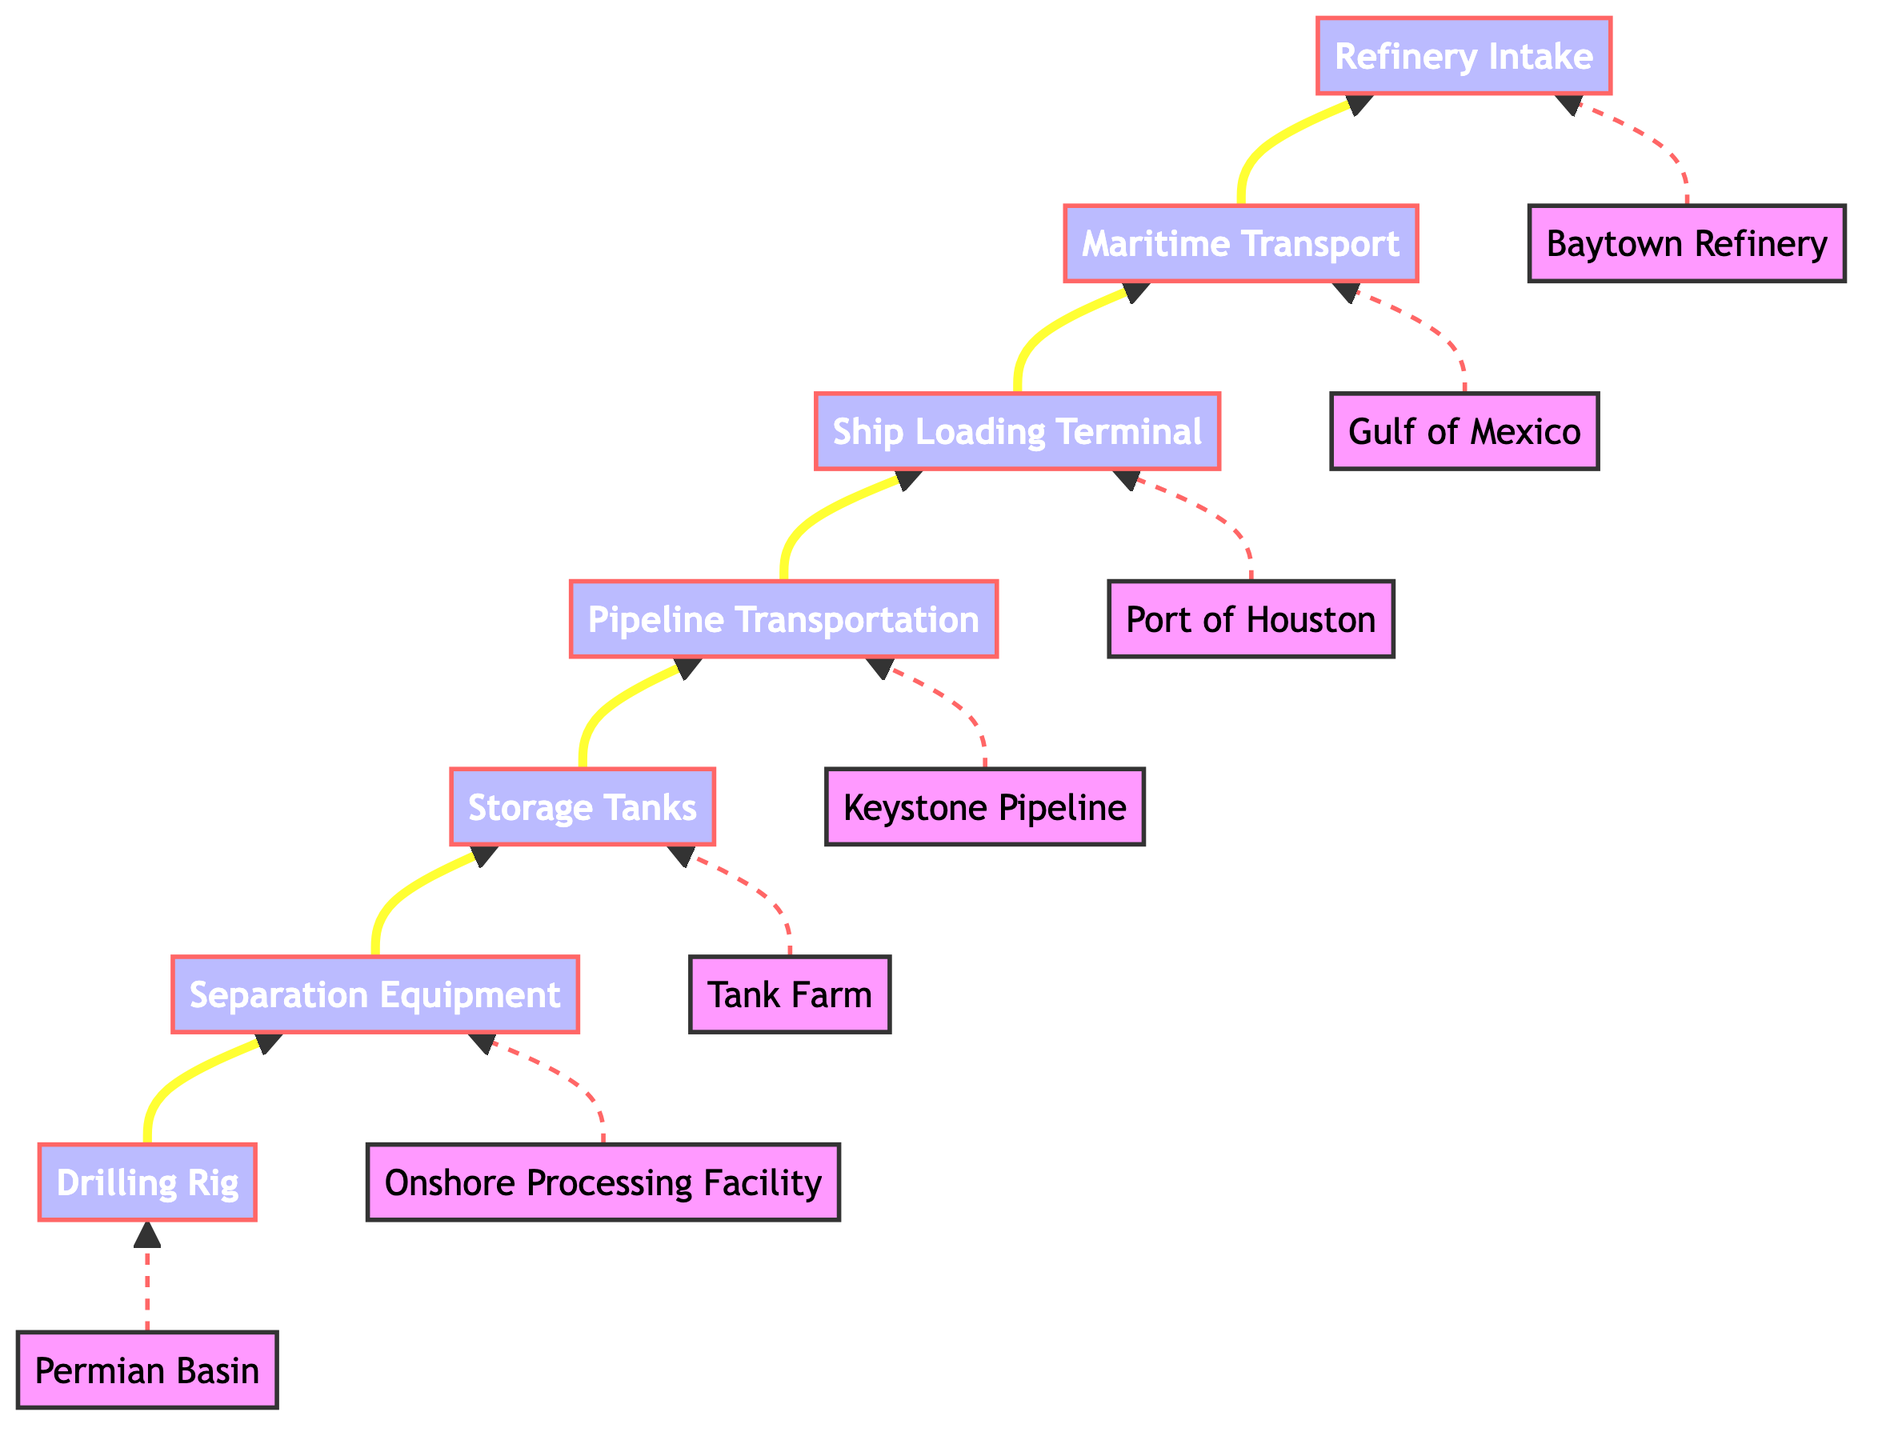What is the starting point of the oil transportation process? The first stage in the process as per the diagram is labeled "Drilling Rig," indicating that this is where crude oil extraction begins.
Answer: Drilling Rig How many stages are there in the oil transportation process? There are a total of seven stages presented in the diagram: Drilling Rig, Separation Equipment, Storage Tanks, Pipeline Transportation, Ship Loading Terminal, Maritime Transport, and Refinery Intake.
Answer: 7 What is the final destination of the oil in the process? The last stage depicted in the flow chart is "Refinery Intake," which indicates that the crude oil is finally received at the refinery for processing.
Answer: Refinery Intake Which stage comes after Pipeline Transportation? As per the flow, the stage that follows "Pipeline Transportation" is the "Ship Loading Terminal," where oil is prepared for transport by tanker ships.
Answer: Ship Loading Terminal What is the specific location of the Separation Equipment? The diagram indicates that the "Separation Equipment" is located at the "Onshore Processing Facility," which specifies where the separation occurs in the process.
Answer: Onshore Processing Facility What is the mode of transport used after the Ship Loading Terminal? After the "Ship Loading Terminal," the process transitions to "Maritime Transport," which involves using tanker ships to move the oil across the seas.
Answer: Maritime Transport What equipment is used at the initial stage for oil extraction? The diagram specifies that "Drilling Rig" is the equipment used to extract crude oil from the ground at the beginning of the process.
Answer: Drilling Rig In which location does the crude oil undergo separation? The separation of oil, water, and gas occurs at the "Onshore Processing Facility," according to the flow chart, indicating where this process takes place.
Answer: Onshore Processing Facility Which pipeline is used for transporting oil to the refinery? The "Keystone Pipeline" is shown in the diagram as the method for transporting crude oil from the storage tanks to the refinery facilities in this process.
Answer: Keystone Pipeline 